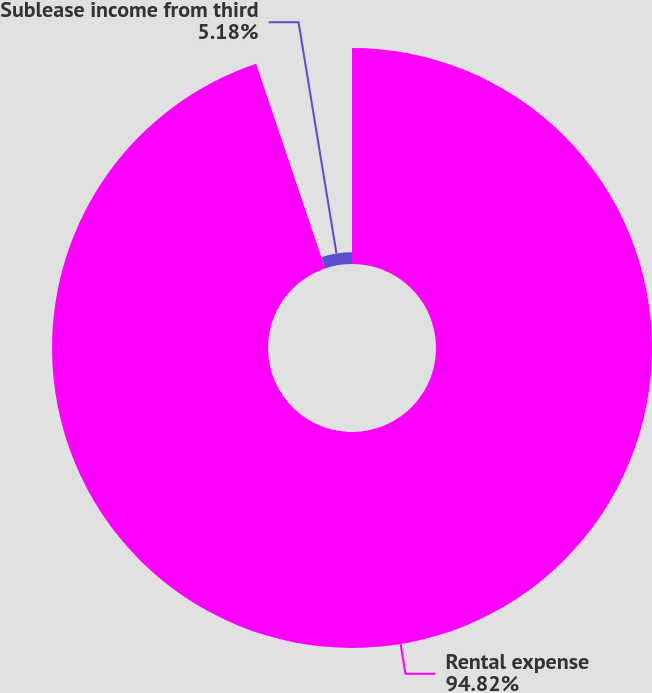<chart> <loc_0><loc_0><loc_500><loc_500><pie_chart><fcel>Rental expense<fcel>Sublease income from third<nl><fcel>94.82%<fcel>5.18%<nl></chart> 